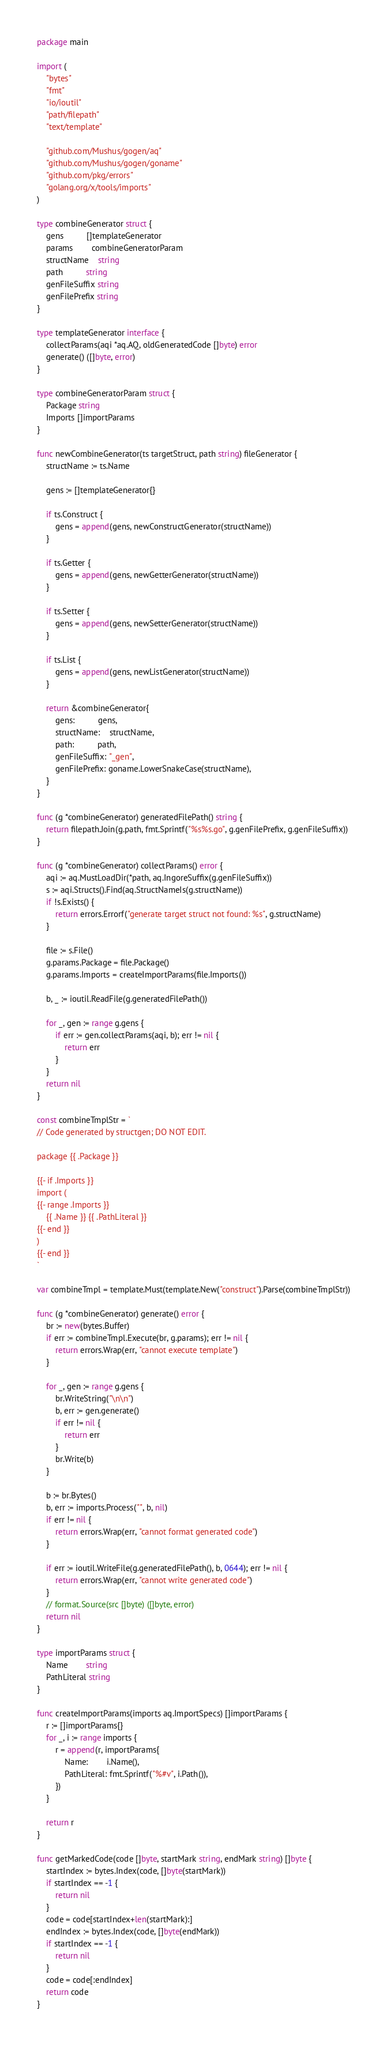Convert code to text. <code><loc_0><loc_0><loc_500><loc_500><_Go_>package main

import (
	"bytes"
	"fmt"
	"io/ioutil"
	"path/filepath"
	"text/template"

	"github.com/Mushus/gogen/aq"
	"github.com/Mushus/gogen/goname"
	"github.com/pkg/errors"
	"golang.org/x/tools/imports"
)

type combineGenerator struct {
	gens          []templateGenerator
	params        combineGeneratorParam
	structName    string
	path          string
	genFileSuffix string
	genFilePrefix string
}

type templateGenerator interface {
	collectParams(aqi *aq.AQ, oldGeneratedCode []byte) error
	generate() ([]byte, error)
}

type combineGeneratorParam struct {
	Package string
	Imports []importParams
}

func newCombineGenerator(ts targetStruct, path string) fileGenerator {
	structName := ts.Name

	gens := []templateGenerator{}

	if ts.Construct {
		gens = append(gens, newConstructGenerator(structName))
	}

	if ts.Getter {
		gens = append(gens, newGetterGenerator(structName))
	}

	if ts.Setter {
		gens = append(gens, newSetterGenerator(structName))
	}

	if ts.List {
		gens = append(gens, newListGenerator(structName))
	}

	return &combineGenerator{
		gens:          gens,
		structName:    structName,
		path:          path,
		genFileSuffix: "_gen",
		genFilePrefix: goname.LowerSnakeCase(structName),
	}
}

func (g *combineGenerator) generatedFilePath() string {
	return filepath.Join(g.path, fmt.Sprintf("%s%s.go", g.genFilePrefix, g.genFileSuffix))
}

func (g *combineGenerator) collectParams() error {
	aqi := aq.MustLoadDir(*path, aq.IngoreSuffix(g.genFileSuffix))
	s := aqi.Structs().Find(aq.StructNameIs(g.structName))
	if !s.Exists() {
		return errors.Errorf("generate target struct not found: %s", g.structName)
	}

	file := s.File()
	g.params.Package = file.Package()
	g.params.Imports = createImportParams(file.Imports())

	b, _ := ioutil.ReadFile(g.generatedFilePath())

	for _, gen := range g.gens {
		if err := gen.collectParams(aqi, b); err != nil {
			return err
		}
	}
	return nil
}

const combineTmplStr = `
// Code generated by structgen; DO NOT EDIT.

package {{ .Package }}

{{- if .Imports }}
import (
{{- range .Imports }}
	{{ .Name }} {{ .PathLiteral }}
{{- end }}
)
{{- end }}
`

var combineTmpl = template.Must(template.New("construct").Parse(combineTmplStr))

func (g *combineGenerator) generate() error {
	br := new(bytes.Buffer)
	if err := combineTmpl.Execute(br, g.params); err != nil {
		return errors.Wrap(err, "cannot execute template")
	}

	for _, gen := range g.gens {
		br.WriteString("\n\n")
		b, err := gen.generate()
		if err != nil {
			return err
		}
		br.Write(b)
	}

	b := br.Bytes()
	b, err := imports.Process("", b, nil)
	if err != nil {
		return errors.Wrap(err, "cannot format generated code")
	}

	if err := ioutil.WriteFile(g.generatedFilePath(), b, 0644); err != nil {
		return errors.Wrap(err, "cannot write generated code")
	}
	// format.Source(src []byte) ([]byte, error)
	return nil
}

type importParams struct {
	Name        string
	PathLiteral string
}

func createImportParams(imports aq.ImportSpecs) []importParams {
	r := []importParams{}
	for _, i := range imports {
		r = append(r, importParams{
			Name:        i.Name(),
			PathLiteral: fmt.Sprintf("%#v", i.Path()),
		})
	}

	return r
}

func getMarkedCode(code []byte, startMark string, endMark string) []byte {
	startIndex := bytes.Index(code, []byte(startMark))
	if startIndex == -1 {
		return nil
	}
	code = code[startIndex+len(startMark):]
	endIndex := bytes.Index(code, []byte(endMark))
	if startIndex == -1 {
		return nil
	}
	code = code[:endIndex]
	return code
}
</code> 